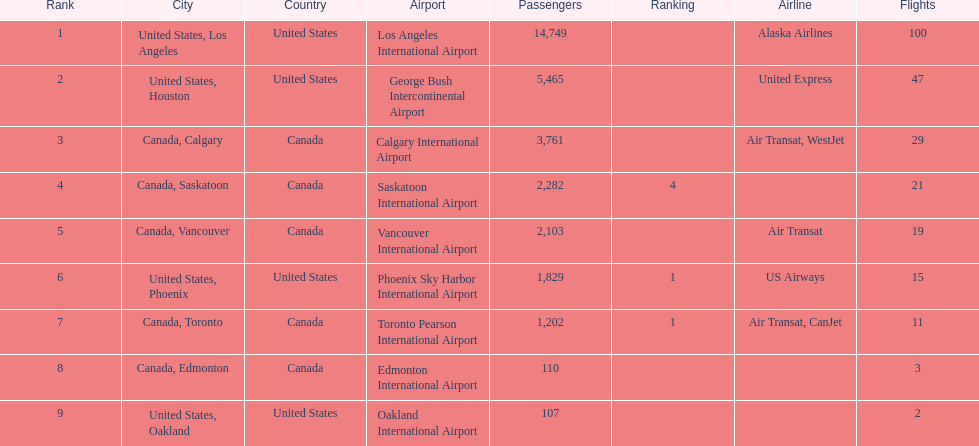The least number of passengers came from which city United States, Oakland. 